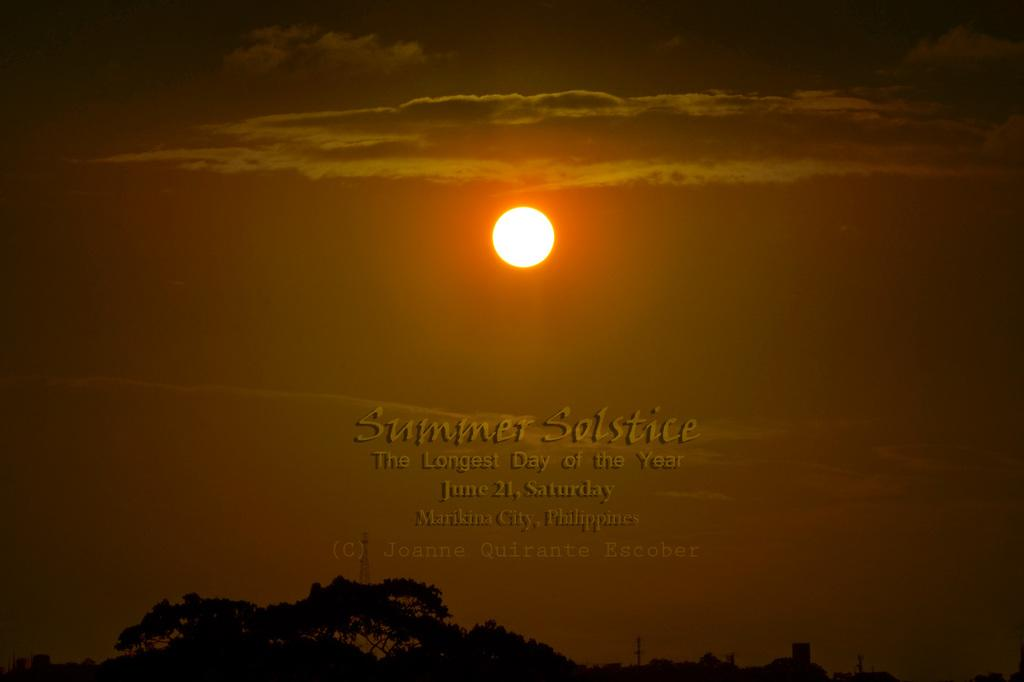What type of vegetation can be seen in the image? There are trees in the image. What is visible in the sky in the image? The sun is visible in the sky, and there are clouds present as well. How many dolls can be seen floating on the water in the image? There are no dolls or water present in the image; it features trees and a sky with the sun and clouds. 